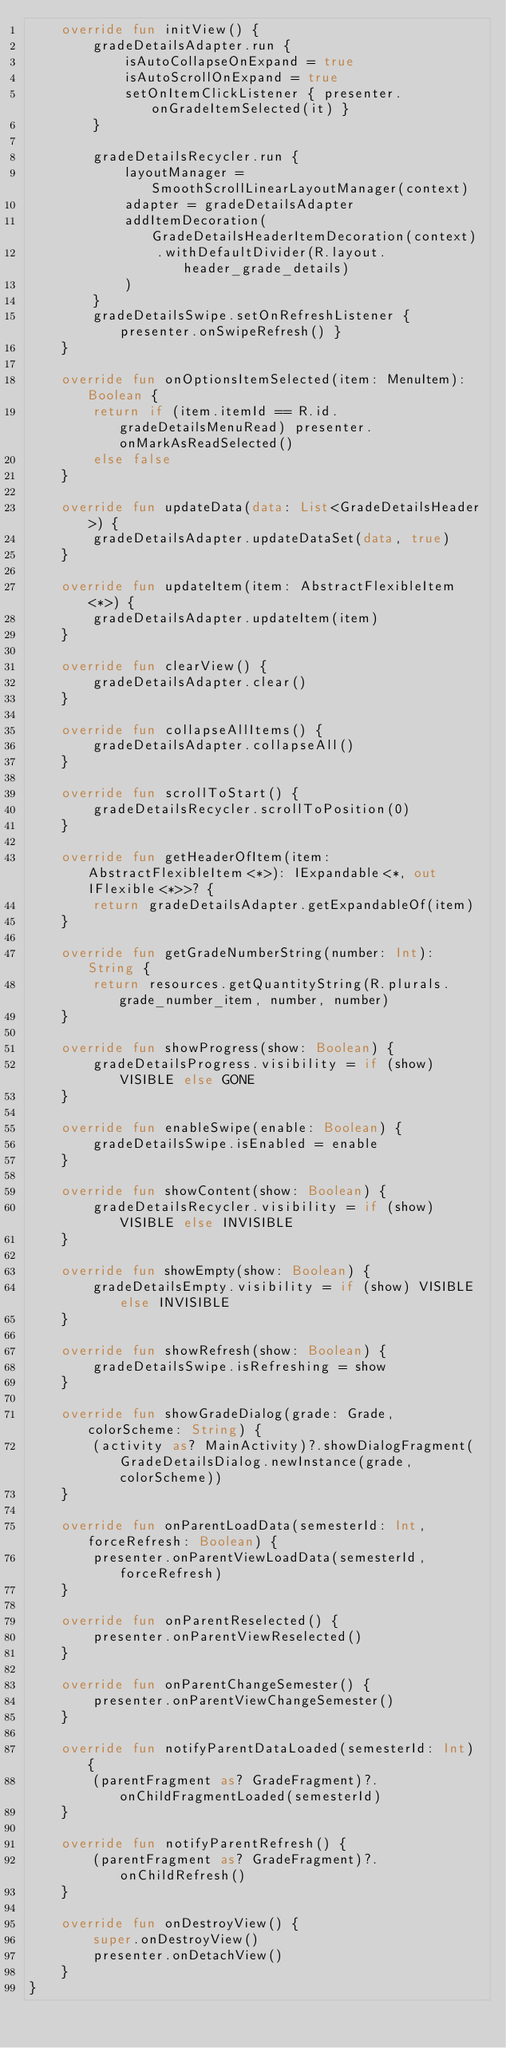<code> <loc_0><loc_0><loc_500><loc_500><_Kotlin_>    override fun initView() {
        gradeDetailsAdapter.run {
            isAutoCollapseOnExpand = true
            isAutoScrollOnExpand = true
            setOnItemClickListener { presenter.onGradeItemSelected(it) }
        }

        gradeDetailsRecycler.run {
            layoutManager = SmoothScrollLinearLayoutManager(context)
            adapter = gradeDetailsAdapter
            addItemDecoration(GradeDetailsHeaderItemDecoration(context)
                .withDefaultDivider(R.layout.header_grade_details)
            )
        }
        gradeDetailsSwipe.setOnRefreshListener { presenter.onSwipeRefresh() }
    }

    override fun onOptionsItemSelected(item: MenuItem): Boolean {
        return if (item.itemId == R.id.gradeDetailsMenuRead) presenter.onMarkAsReadSelected()
        else false
    }

    override fun updateData(data: List<GradeDetailsHeader>) {
        gradeDetailsAdapter.updateDataSet(data, true)
    }

    override fun updateItem(item: AbstractFlexibleItem<*>) {
        gradeDetailsAdapter.updateItem(item)
    }

    override fun clearView() {
        gradeDetailsAdapter.clear()
    }

    override fun collapseAllItems() {
        gradeDetailsAdapter.collapseAll()
    }

    override fun scrollToStart() {
        gradeDetailsRecycler.scrollToPosition(0)
    }

    override fun getHeaderOfItem(item: AbstractFlexibleItem<*>): IExpandable<*, out IFlexible<*>>? {
        return gradeDetailsAdapter.getExpandableOf(item)
    }

    override fun getGradeNumberString(number: Int): String {
        return resources.getQuantityString(R.plurals.grade_number_item, number, number)
    }

    override fun showProgress(show: Boolean) {
        gradeDetailsProgress.visibility = if (show) VISIBLE else GONE
    }

    override fun enableSwipe(enable: Boolean) {
        gradeDetailsSwipe.isEnabled = enable
    }

    override fun showContent(show: Boolean) {
        gradeDetailsRecycler.visibility = if (show) VISIBLE else INVISIBLE
    }

    override fun showEmpty(show: Boolean) {
        gradeDetailsEmpty.visibility = if (show) VISIBLE else INVISIBLE
    }

    override fun showRefresh(show: Boolean) {
        gradeDetailsSwipe.isRefreshing = show
    }

    override fun showGradeDialog(grade: Grade, colorScheme: String) {
        (activity as? MainActivity)?.showDialogFragment(GradeDetailsDialog.newInstance(grade, colorScheme))
    }

    override fun onParentLoadData(semesterId: Int, forceRefresh: Boolean) {
        presenter.onParentViewLoadData(semesterId, forceRefresh)
    }

    override fun onParentReselected() {
        presenter.onParentViewReselected()
    }

    override fun onParentChangeSemester() {
        presenter.onParentViewChangeSemester()
    }

    override fun notifyParentDataLoaded(semesterId: Int) {
        (parentFragment as? GradeFragment)?.onChildFragmentLoaded(semesterId)
    }

    override fun notifyParentRefresh() {
        (parentFragment as? GradeFragment)?.onChildRefresh()
    }

    override fun onDestroyView() {
        super.onDestroyView()
        presenter.onDetachView()
    }
}
</code> 